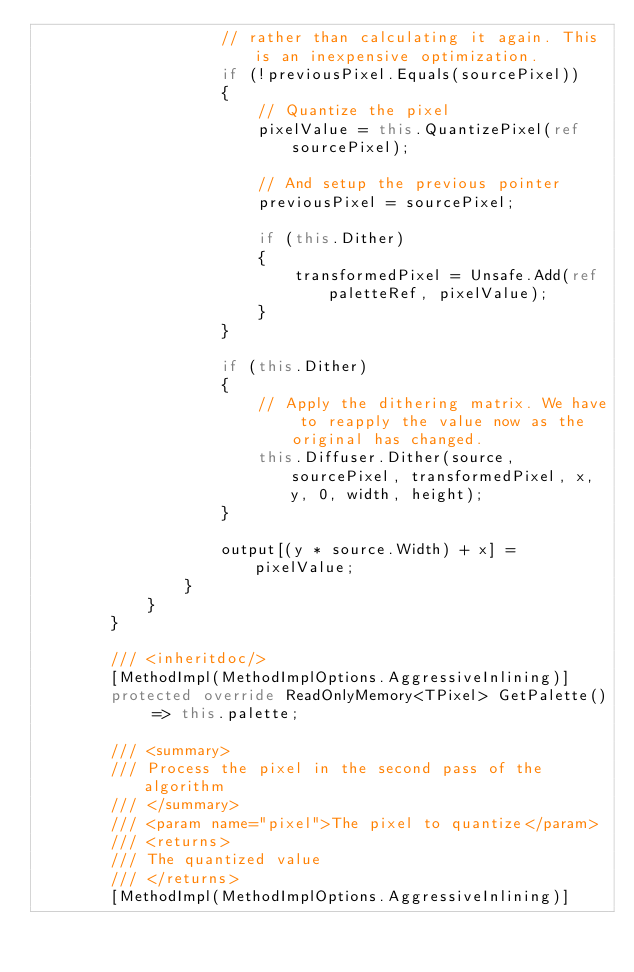Convert code to text. <code><loc_0><loc_0><loc_500><loc_500><_C#_>                    // rather than calculating it again. This is an inexpensive optimization.
                    if (!previousPixel.Equals(sourcePixel))
                    {
                        // Quantize the pixel
                        pixelValue = this.QuantizePixel(ref sourcePixel);

                        // And setup the previous pointer
                        previousPixel = sourcePixel;

                        if (this.Dither)
                        {
                            transformedPixel = Unsafe.Add(ref paletteRef, pixelValue);
                        }
                    }

                    if (this.Dither)
                    {
                        // Apply the dithering matrix. We have to reapply the value now as the original has changed.
                        this.Diffuser.Dither(source, sourcePixel, transformedPixel, x, y, 0, width, height);
                    }

                    output[(y * source.Width) + x] = pixelValue;
                }
            }
        }

        /// <inheritdoc/>
        [MethodImpl(MethodImplOptions.AggressiveInlining)]
        protected override ReadOnlyMemory<TPixel> GetPalette() => this.palette;

        /// <summary>
        /// Process the pixel in the second pass of the algorithm
        /// </summary>
        /// <param name="pixel">The pixel to quantize</param>
        /// <returns>
        /// The quantized value
        /// </returns>
        [MethodImpl(MethodImplOptions.AggressiveInlining)]</code> 